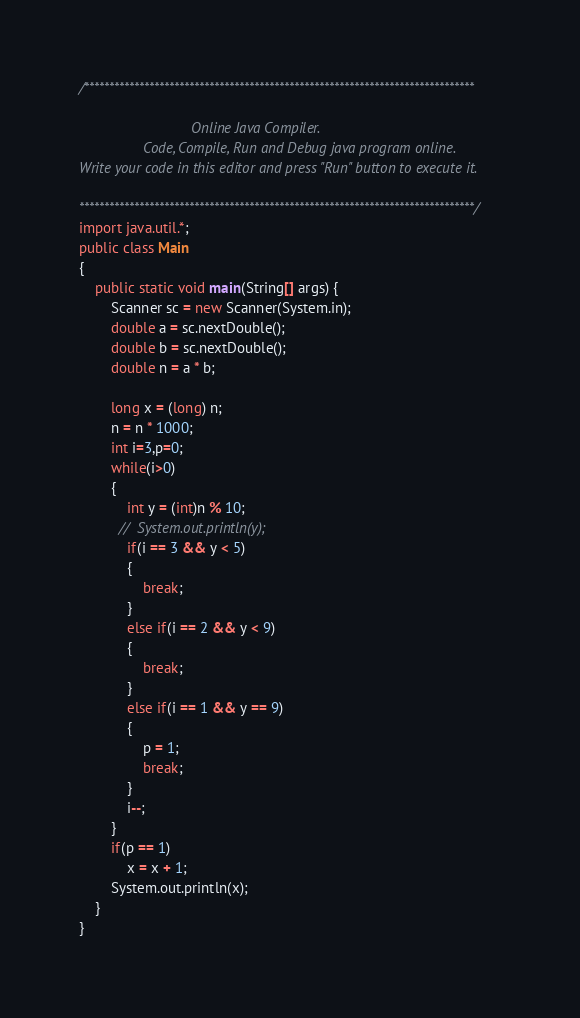<code> <loc_0><loc_0><loc_500><loc_500><_Java_>/******************************************************************************

                            Online Java Compiler.
                Code, Compile, Run and Debug java program online.
Write your code in this editor and press "Run" button to execute it.

*******************************************************************************/
import java.util.*;
public class Main
{
	public static void main(String[] args) {
		Scanner sc = new Scanner(System.in);
		double a = sc.nextDouble();
		double b = sc.nextDouble();
		double n = a * b;
		
		long x = (long) n;
		n = n * 1000;
		int i=3,p=0;
		while(i>0)
		{
		    int y = (int)n % 10;
		  //  System.out.println(y);
		    if(i == 3 && y < 5)
		    {
		        break;
		    }
		    else if(i == 2 && y < 9)
		    {
		        break;
		    }
		    else if(i == 1 && y == 9)
		    {
		        p = 1;
		        break;
		    }
		    i--;
		}
		if(p == 1)
		    x = x + 1;
		System.out.println(x);
	}
}
</code> 